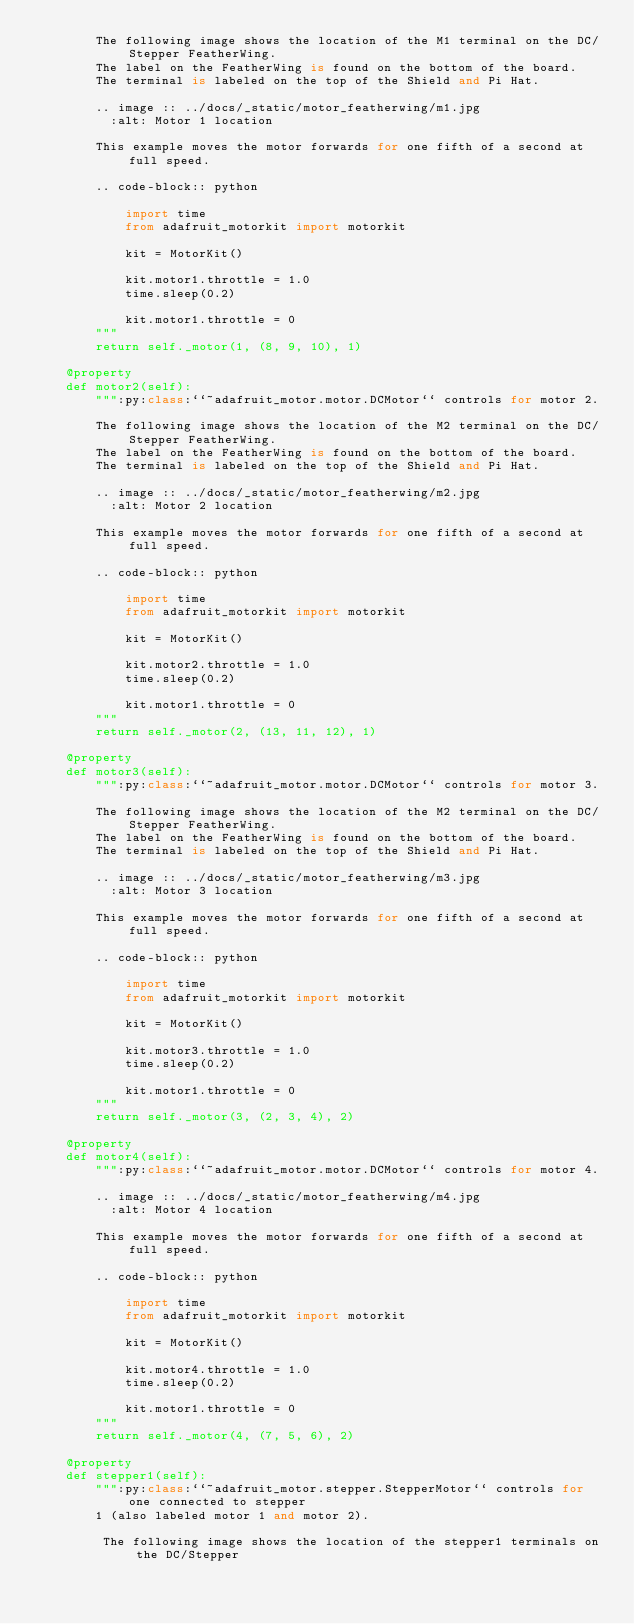Convert code to text. <code><loc_0><loc_0><loc_500><loc_500><_Python_>        The following image shows the location of the M1 terminal on the DC/Stepper FeatherWing.
        The label on the FeatherWing is found on the bottom of the board.
        The terminal is labeled on the top of the Shield and Pi Hat.

        .. image :: ../docs/_static/motor_featherwing/m1.jpg
          :alt: Motor 1 location

        This example moves the motor forwards for one fifth of a second at full speed.

        .. code-block:: python

            import time
            from adafruit_motorkit import motorkit

            kit = MotorKit()

            kit.motor1.throttle = 1.0
            time.sleep(0.2)

            kit.motor1.throttle = 0
        """
        return self._motor(1, (8, 9, 10), 1)

    @property
    def motor2(self):
        """:py:class:``~adafruit_motor.motor.DCMotor`` controls for motor 2.

        The following image shows the location of the M2 terminal on the DC/Stepper FeatherWing.
        The label on the FeatherWing is found on the bottom of the board.
        The terminal is labeled on the top of the Shield and Pi Hat.

        .. image :: ../docs/_static/motor_featherwing/m2.jpg
          :alt: Motor 2 location

        This example moves the motor forwards for one fifth of a second at full speed.

        .. code-block:: python

            import time
            from adafruit_motorkit import motorkit

            kit = MotorKit()

            kit.motor2.throttle = 1.0
            time.sleep(0.2)

            kit.motor1.throttle = 0
        """
        return self._motor(2, (13, 11, 12), 1)

    @property
    def motor3(self):
        """:py:class:``~adafruit_motor.motor.DCMotor`` controls for motor 3.

        The following image shows the location of the M2 terminal on the DC/Stepper FeatherWing.
        The label on the FeatherWing is found on the bottom of the board.
        The terminal is labeled on the top of the Shield and Pi Hat.

        .. image :: ../docs/_static/motor_featherwing/m3.jpg
          :alt: Motor 3 location

        This example moves the motor forwards for one fifth of a second at full speed.

        .. code-block:: python

            import time
            from adafruit_motorkit import motorkit

            kit = MotorKit()

            kit.motor3.throttle = 1.0
            time.sleep(0.2)

            kit.motor1.throttle = 0
        """
        return self._motor(3, (2, 3, 4), 2)

    @property
    def motor4(self):
        """:py:class:``~adafruit_motor.motor.DCMotor`` controls for motor 4.

        .. image :: ../docs/_static/motor_featherwing/m4.jpg
          :alt: Motor 4 location

        This example moves the motor forwards for one fifth of a second at full speed.

        .. code-block:: python

            import time
            from adafruit_motorkit import motorkit

            kit = MotorKit()

            kit.motor4.throttle = 1.0
            time.sleep(0.2)

            kit.motor1.throttle = 0
        """
        return self._motor(4, (7, 5, 6), 2)

    @property
    def stepper1(self):
        """:py:class:``~adafruit_motor.stepper.StepperMotor`` controls for one connected to stepper
        1 (also labeled motor 1 and motor 2).

         The following image shows the location of the stepper1 terminals on the DC/Stepper</code> 